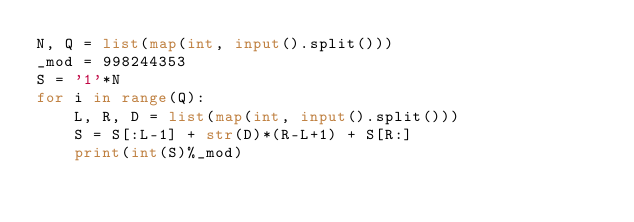<code> <loc_0><loc_0><loc_500><loc_500><_Python_>N, Q = list(map(int, input().split()))
_mod = 998244353
S = '1'*N
for i in range(Q):
    L, R, D = list(map(int, input().split()))
    S = S[:L-1] + str(D)*(R-L+1) + S[R:]
    print(int(S)%_mod)</code> 